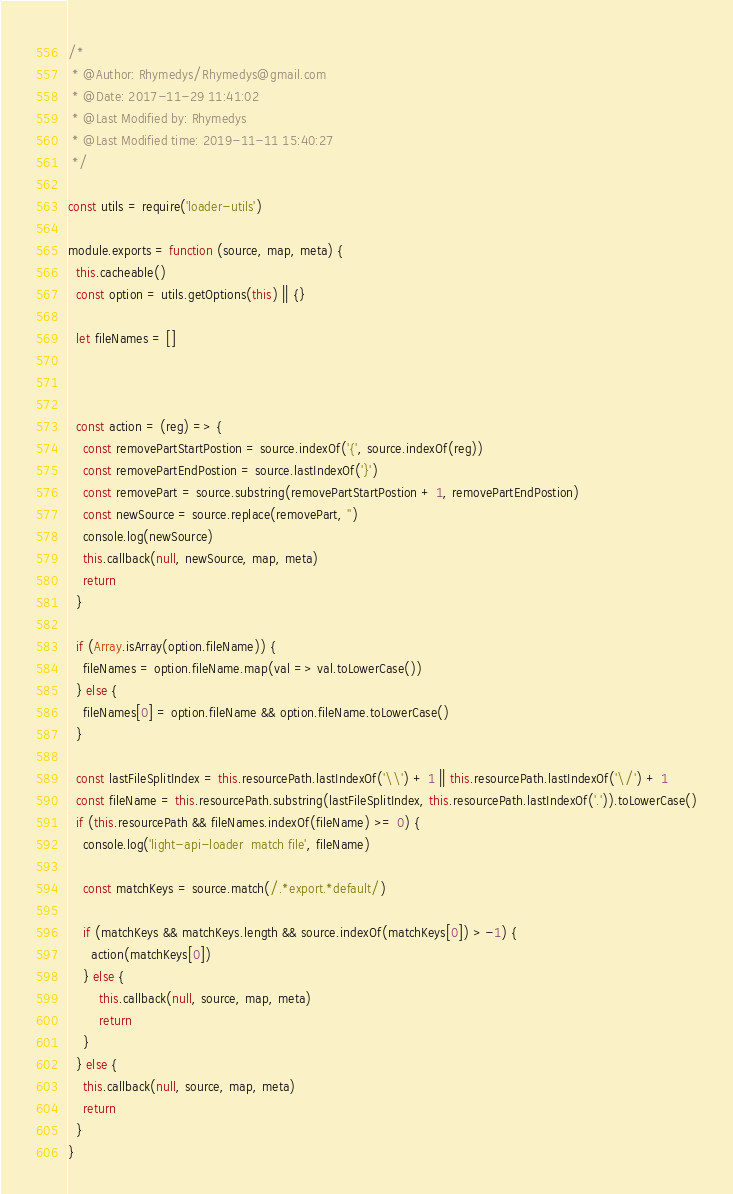Convert code to text. <code><loc_0><loc_0><loc_500><loc_500><_JavaScript_>/*
 * @Author: Rhymedys/Rhymedys@gmail.com
 * @Date: 2017-11-29 11:41:02
 * @Last Modified by: Rhymedys
 * @Last Modified time: 2019-11-11 15:40:27
 */

const utils = require('loader-utils')

module.exports = function (source, map, meta) {
  this.cacheable()
  const option = utils.getOptions(this) || {}

  let fileNames = []



  const action = (reg) => {
    const removePartStartPostion = source.indexOf('{', source.indexOf(reg))
    const removePartEndPostion = source.lastIndexOf('}')
    const removePart = source.substring(removePartStartPostion + 1, removePartEndPostion)
    const newSource = source.replace(removePart, '')
    console.log(newSource)
    this.callback(null, newSource, map, meta)
    return
  }

  if (Array.isArray(option.fileName)) {
    fileNames = option.fileName.map(val => val.toLowerCase())
  } else {
    fileNames[0] = option.fileName && option.fileName.toLowerCase()
  }

  const lastFileSplitIndex = this.resourcePath.lastIndexOf('\\') + 1 || this.resourcePath.lastIndexOf('\/') + 1
  const fileName = this.resourcePath.substring(lastFileSplitIndex, this.resourcePath.lastIndexOf('.')).toLowerCase()
  if (this.resourcePath && fileNames.indexOf(fileName) >= 0) {
    console.log('light-api-loader  match file', fileName)

    const matchKeys = source.match(/.*export.*default/)
    
    if (matchKeys && matchKeys.length && source.indexOf(matchKeys[0]) > -1) {
      action(matchKeys[0])
    } else {
        this.callback(null, source, map, meta)
        return
    }
  } else {
    this.callback(null, source, map, meta)
    return
  }
}</code> 